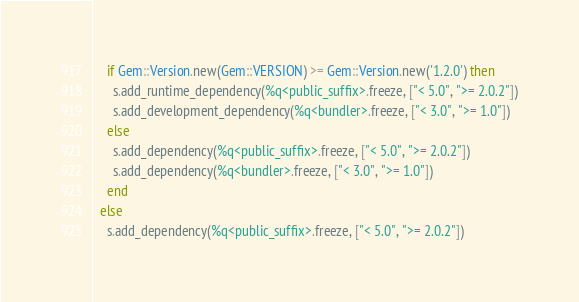Convert code to text. <code><loc_0><loc_0><loc_500><loc_500><_Ruby_>    if Gem::Version.new(Gem::VERSION) >= Gem::Version.new('1.2.0') then
      s.add_runtime_dependency(%q<public_suffix>.freeze, ["< 5.0", ">= 2.0.2"])
      s.add_development_dependency(%q<bundler>.freeze, ["< 3.0", ">= 1.0"])
    else
      s.add_dependency(%q<public_suffix>.freeze, ["< 5.0", ">= 2.0.2"])
      s.add_dependency(%q<bundler>.freeze, ["< 3.0", ">= 1.0"])
    end
  else
    s.add_dependency(%q<public_suffix>.freeze, ["< 5.0", ">= 2.0.2"])</code> 